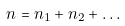<formula> <loc_0><loc_0><loc_500><loc_500>n = n _ { 1 } + n _ { 2 } + \dots</formula> 